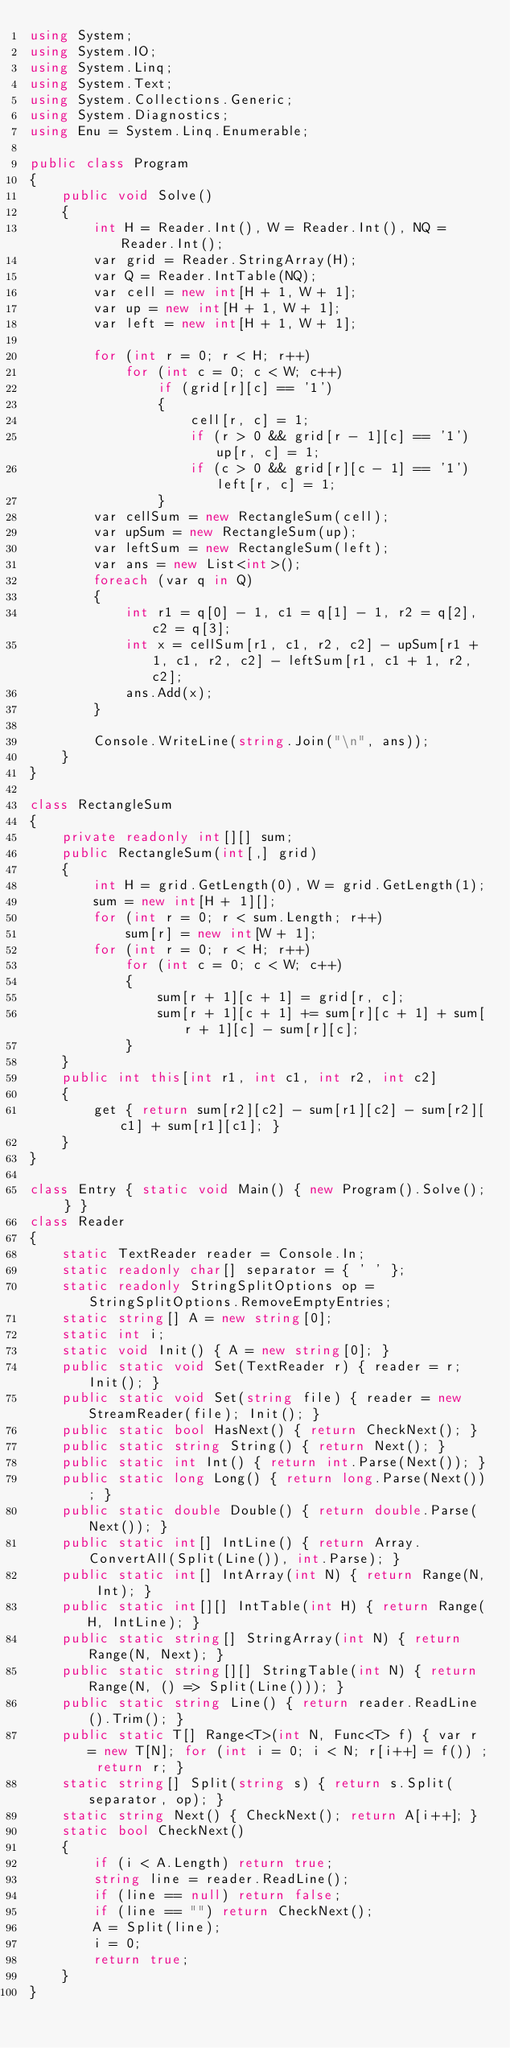Convert code to text. <code><loc_0><loc_0><loc_500><loc_500><_C#_>using System;
using System.IO;
using System.Linq;
using System.Text;
using System.Collections.Generic;
using System.Diagnostics;
using Enu = System.Linq.Enumerable;

public class Program
{
    public void Solve()
    {
        int H = Reader.Int(), W = Reader.Int(), NQ = Reader.Int();
        var grid = Reader.StringArray(H);
        var Q = Reader.IntTable(NQ);
        var cell = new int[H + 1, W + 1];
        var up = new int[H + 1, W + 1];
        var left = new int[H + 1, W + 1];

        for (int r = 0; r < H; r++)
            for (int c = 0; c < W; c++)
                if (grid[r][c] == '1')
                {
                    cell[r, c] = 1;
                    if (r > 0 && grid[r - 1][c] == '1') up[r, c] = 1;
                    if (c > 0 && grid[r][c - 1] == '1') left[r, c] = 1;
                }
        var cellSum = new RectangleSum(cell);
        var upSum = new RectangleSum(up);
        var leftSum = new RectangleSum(left);
        var ans = new List<int>();
        foreach (var q in Q)
        {
            int r1 = q[0] - 1, c1 = q[1] - 1, r2 = q[2], c2 = q[3];
            int x = cellSum[r1, c1, r2, c2] - upSum[r1 + 1, c1, r2, c2] - leftSum[r1, c1 + 1, r2, c2];
            ans.Add(x);
        }

        Console.WriteLine(string.Join("\n", ans));
    }
}

class RectangleSum
{
    private readonly int[][] sum;
    public RectangleSum(int[,] grid)
    {
        int H = grid.GetLength(0), W = grid.GetLength(1);
        sum = new int[H + 1][];
        for (int r = 0; r < sum.Length; r++)
            sum[r] = new int[W + 1];
        for (int r = 0; r < H; r++)
            for (int c = 0; c < W; c++)
            {
                sum[r + 1][c + 1] = grid[r, c];
                sum[r + 1][c + 1] += sum[r][c + 1] + sum[r + 1][c] - sum[r][c];
            }
    }
    public int this[int r1, int c1, int r2, int c2]
    {
        get { return sum[r2][c2] - sum[r1][c2] - sum[r2][c1] + sum[r1][c1]; }
    }
}

class Entry { static void Main() { new Program().Solve(); } }
class Reader
{
    static TextReader reader = Console.In;
    static readonly char[] separator = { ' ' };
    static readonly StringSplitOptions op = StringSplitOptions.RemoveEmptyEntries;
    static string[] A = new string[0];
    static int i;
    static void Init() { A = new string[0]; }
    public static void Set(TextReader r) { reader = r; Init(); }
    public static void Set(string file) { reader = new StreamReader(file); Init(); }
    public static bool HasNext() { return CheckNext(); }
    public static string String() { return Next(); }
    public static int Int() { return int.Parse(Next()); }
    public static long Long() { return long.Parse(Next()); }
    public static double Double() { return double.Parse(Next()); }
    public static int[] IntLine() { return Array.ConvertAll(Split(Line()), int.Parse); }
    public static int[] IntArray(int N) { return Range(N, Int); }
    public static int[][] IntTable(int H) { return Range(H, IntLine); }
    public static string[] StringArray(int N) { return Range(N, Next); }
    public static string[][] StringTable(int N) { return Range(N, () => Split(Line())); }
    public static string Line() { return reader.ReadLine().Trim(); }
    public static T[] Range<T>(int N, Func<T> f) { var r = new T[N]; for (int i = 0; i < N; r[i++] = f()) ; return r; }
    static string[] Split(string s) { return s.Split(separator, op); }
    static string Next() { CheckNext(); return A[i++]; }
    static bool CheckNext()
    {
        if (i < A.Length) return true;
        string line = reader.ReadLine();
        if (line == null) return false;
        if (line == "") return CheckNext();
        A = Split(line);
        i = 0;
        return true;
    }
}</code> 